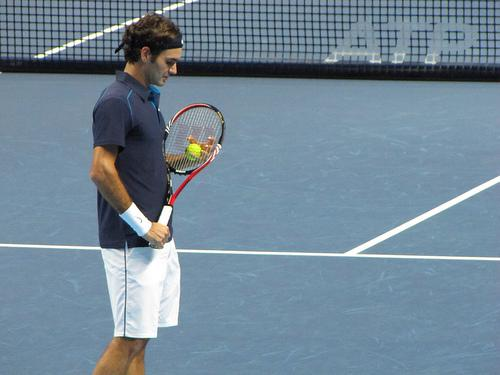Question: who is pictured?
Choices:
A. A baseball player.
B. A librarian.
C. A tennis player.
D. A kid drinking orange juice.
Answer with the letter. Answer: C Question: what color is the tennis ball?
Choices:
A. Yellow.
B. Green.
C. White.
D. Orange.
Answer with the letter. Answer: A Question: what is written on the net?
Choices:
A. ATP.
B. Net.
C. Danger.
D. Cf5.
Answer with the letter. Answer: A Question: what is the man holding in his right hand?
Choices:
A. A hot dog.
B. A baseball bat.
C. A tennis racket.
D. A basketball.
Answer with the letter. Answer: C 